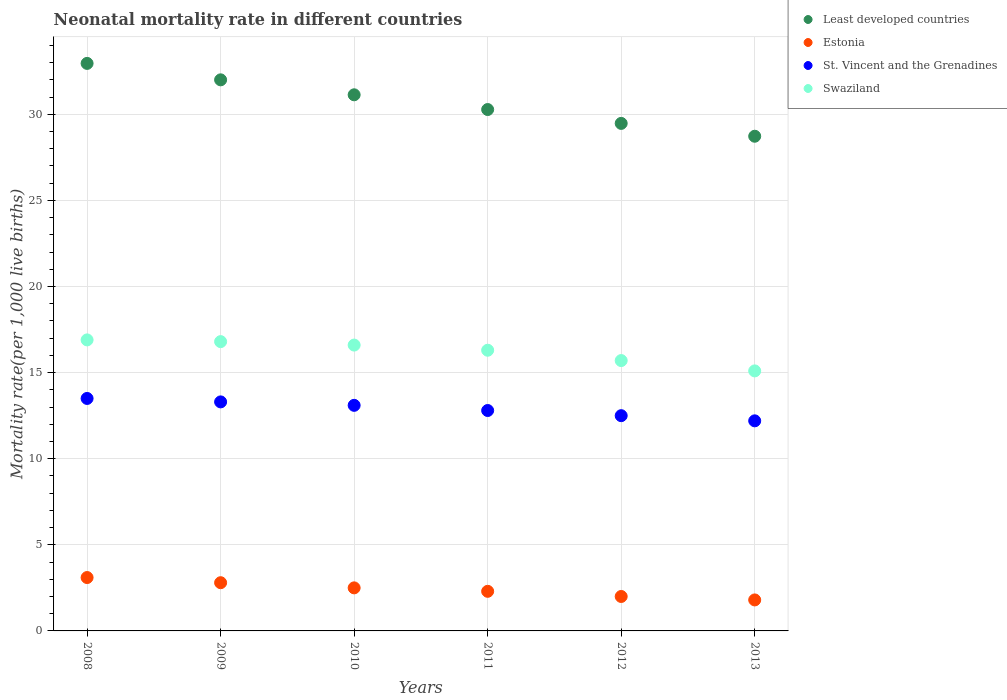How many different coloured dotlines are there?
Ensure brevity in your answer.  4. What is the neonatal mortality rate in Estonia in 2011?
Your response must be concise. 2.3. Across all years, what is the minimum neonatal mortality rate in Least developed countries?
Make the answer very short. 28.73. In which year was the neonatal mortality rate in Swaziland maximum?
Offer a very short reply. 2008. What is the total neonatal mortality rate in Estonia in the graph?
Your response must be concise. 14.5. What is the difference between the neonatal mortality rate in Least developed countries in 2009 and that in 2010?
Keep it short and to the point. 0.87. What is the difference between the neonatal mortality rate in St. Vincent and the Grenadines in 2008 and the neonatal mortality rate in Least developed countries in 2009?
Offer a very short reply. -18.5. What is the average neonatal mortality rate in Estonia per year?
Your response must be concise. 2.42. In the year 2013, what is the difference between the neonatal mortality rate in Swaziland and neonatal mortality rate in St. Vincent and the Grenadines?
Give a very brief answer. 2.9. In how many years, is the neonatal mortality rate in Swaziland greater than 6?
Your answer should be compact. 6. What is the ratio of the neonatal mortality rate in Least developed countries in 2011 to that in 2012?
Your answer should be compact. 1.03. Is the difference between the neonatal mortality rate in Swaziland in 2011 and 2012 greater than the difference between the neonatal mortality rate in St. Vincent and the Grenadines in 2011 and 2012?
Offer a terse response. Yes. What is the difference between the highest and the second highest neonatal mortality rate in Least developed countries?
Offer a very short reply. 0.95. What is the difference between the highest and the lowest neonatal mortality rate in Swaziland?
Provide a short and direct response. 1.8. Is it the case that in every year, the sum of the neonatal mortality rate in St. Vincent and the Grenadines and neonatal mortality rate in Least developed countries  is greater than the sum of neonatal mortality rate in Swaziland and neonatal mortality rate in Estonia?
Offer a very short reply. Yes. Is the neonatal mortality rate in Least developed countries strictly greater than the neonatal mortality rate in Estonia over the years?
Offer a very short reply. Yes. Is the neonatal mortality rate in Swaziland strictly less than the neonatal mortality rate in St. Vincent and the Grenadines over the years?
Provide a succinct answer. No. How many years are there in the graph?
Your response must be concise. 6. What is the difference between two consecutive major ticks on the Y-axis?
Give a very brief answer. 5. Does the graph contain any zero values?
Offer a very short reply. No. Does the graph contain grids?
Your response must be concise. Yes. Where does the legend appear in the graph?
Your response must be concise. Top right. What is the title of the graph?
Your answer should be compact. Neonatal mortality rate in different countries. What is the label or title of the Y-axis?
Provide a succinct answer. Mortality rate(per 1,0 live births). What is the Mortality rate(per 1,000 live births) of Least developed countries in 2008?
Make the answer very short. 32.96. What is the Mortality rate(per 1,000 live births) in St. Vincent and the Grenadines in 2008?
Your answer should be compact. 13.5. What is the Mortality rate(per 1,000 live births) in Least developed countries in 2009?
Offer a terse response. 32. What is the Mortality rate(per 1,000 live births) in St. Vincent and the Grenadines in 2009?
Your answer should be compact. 13.3. What is the Mortality rate(per 1,000 live births) in Least developed countries in 2010?
Provide a succinct answer. 31.13. What is the Mortality rate(per 1,000 live births) in Estonia in 2010?
Keep it short and to the point. 2.5. What is the Mortality rate(per 1,000 live births) of St. Vincent and the Grenadines in 2010?
Your answer should be compact. 13.1. What is the Mortality rate(per 1,000 live births) in Least developed countries in 2011?
Your response must be concise. 30.28. What is the Mortality rate(per 1,000 live births) in Estonia in 2011?
Offer a terse response. 2.3. What is the Mortality rate(per 1,000 live births) of St. Vincent and the Grenadines in 2011?
Provide a short and direct response. 12.8. What is the Mortality rate(per 1,000 live births) in Least developed countries in 2012?
Provide a short and direct response. 29.47. What is the Mortality rate(per 1,000 live births) of Estonia in 2012?
Give a very brief answer. 2. What is the Mortality rate(per 1,000 live births) in Least developed countries in 2013?
Provide a succinct answer. 28.73. What is the Mortality rate(per 1,000 live births) in St. Vincent and the Grenadines in 2013?
Offer a terse response. 12.2. Across all years, what is the maximum Mortality rate(per 1,000 live births) of Least developed countries?
Make the answer very short. 32.96. Across all years, what is the maximum Mortality rate(per 1,000 live births) in Swaziland?
Offer a terse response. 16.9. Across all years, what is the minimum Mortality rate(per 1,000 live births) of Least developed countries?
Provide a short and direct response. 28.73. Across all years, what is the minimum Mortality rate(per 1,000 live births) of Estonia?
Your answer should be very brief. 1.8. Across all years, what is the minimum Mortality rate(per 1,000 live births) in Swaziland?
Offer a terse response. 15.1. What is the total Mortality rate(per 1,000 live births) in Least developed countries in the graph?
Make the answer very short. 184.57. What is the total Mortality rate(per 1,000 live births) in Estonia in the graph?
Your answer should be very brief. 14.5. What is the total Mortality rate(per 1,000 live births) of St. Vincent and the Grenadines in the graph?
Your response must be concise. 77.4. What is the total Mortality rate(per 1,000 live births) of Swaziland in the graph?
Provide a succinct answer. 97.4. What is the difference between the Mortality rate(per 1,000 live births) of Least developed countries in 2008 and that in 2009?
Your response must be concise. 0.95. What is the difference between the Mortality rate(per 1,000 live births) in Estonia in 2008 and that in 2009?
Your answer should be compact. 0.3. What is the difference between the Mortality rate(per 1,000 live births) in Least developed countries in 2008 and that in 2010?
Make the answer very short. 1.82. What is the difference between the Mortality rate(per 1,000 live births) of Estonia in 2008 and that in 2010?
Your response must be concise. 0.6. What is the difference between the Mortality rate(per 1,000 live births) of Swaziland in 2008 and that in 2010?
Give a very brief answer. 0.3. What is the difference between the Mortality rate(per 1,000 live births) of Least developed countries in 2008 and that in 2011?
Ensure brevity in your answer.  2.68. What is the difference between the Mortality rate(per 1,000 live births) in St. Vincent and the Grenadines in 2008 and that in 2011?
Provide a short and direct response. 0.7. What is the difference between the Mortality rate(per 1,000 live births) in Swaziland in 2008 and that in 2011?
Provide a succinct answer. 0.6. What is the difference between the Mortality rate(per 1,000 live births) of Least developed countries in 2008 and that in 2012?
Offer a very short reply. 3.48. What is the difference between the Mortality rate(per 1,000 live births) in St. Vincent and the Grenadines in 2008 and that in 2012?
Make the answer very short. 1. What is the difference between the Mortality rate(per 1,000 live births) of Swaziland in 2008 and that in 2012?
Offer a very short reply. 1.2. What is the difference between the Mortality rate(per 1,000 live births) in Least developed countries in 2008 and that in 2013?
Provide a succinct answer. 4.23. What is the difference between the Mortality rate(per 1,000 live births) of St. Vincent and the Grenadines in 2008 and that in 2013?
Your answer should be very brief. 1.3. What is the difference between the Mortality rate(per 1,000 live births) of Least developed countries in 2009 and that in 2010?
Your answer should be very brief. 0.87. What is the difference between the Mortality rate(per 1,000 live births) of Estonia in 2009 and that in 2010?
Make the answer very short. 0.3. What is the difference between the Mortality rate(per 1,000 live births) of Least developed countries in 2009 and that in 2011?
Your answer should be compact. 1.72. What is the difference between the Mortality rate(per 1,000 live births) in Least developed countries in 2009 and that in 2012?
Your answer should be very brief. 2.53. What is the difference between the Mortality rate(per 1,000 live births) of Swaziland in 2009 and that in 2012?
Give a very brief answer. 1.1. What is the difference between the Mortality rate(per 1,000 live births) of Least developed countries in 2009 and that in 2013?
Give a very brief answer. 3.28. What is the difference between the Mortality rate(per 1,000 live births) of St. Vincent and the Grenadines in 2009 and that in 2013?
Your answer should be compact. 1.1. What is the difference between the Mortality rate(per 1,000 live births) of Least developed countries in 2010 and that in 2011?
Provide a succinct answer. 0.86. What is the difference between the Mortality rate(per 1,000 live births) of Swaziland in 2010 and that in 2011?
Offer a very short reply. 0.3. What is the difference between the Mortality rate(per 1,000 live births) in Least developed countries in 2010 and that in 2012?
Make the answer very short. 1.66. What is the difference between the Mortality rate(per 1,000 live births) in Swaziland in 2010 and that in 2012?
Your response must be concise. 0.9. What is the difference between the Mortality rate(per 1,000 live births) of Least developed countries in 2010 and that in 2013?
Keep it short and to the point. 2.41. What is the difference between the Mortality rate(per 1,000 live births) of Estonia in 2010 and that in 2013?
Offer a terse response. 0.7. What is the difference between the Mortality rate(per 1,000 live births) in Swaziland in 2010 and that in 2013?
Offer a terse response. 1.5. What is the difference between the Mortality rate(per 1,000 live births) of Least developed countries in 2011 and that in 2012?
Your answer should be compact. 0.81. What is the difference between the Mortality rate(per 1,000 live births) in Estonia in 2011 and that in 2012?
Keep it short and to the point. 0.3. What is the difference between the Mortality rate(per 1,000 live births) in St. Vincent and the Grenadines in 2011 and that in 2012?
Keep it short and to the point. 0.3. What is the difference between the Mortality rate(per 1,000 live births) of Least developed countries in 2011 and that in 2013?
Give a very brief answer. 1.55. What is the difference between the Mortality rate(per 1,000 live births) of Estonia in 2011 and that in 2013?
Keep it short and to the point. 0.5. What is the difference between the Mortality rate(per 1,000 live births) of Swaziland in 2011 and that in 2013?
Make the answer very short. 1.2. What is the difference between the Mortality rate(per 1,000 live births) in Least developed countries in 2012 and that in 2013?
Give a very brief answer. 0.75. What is the difference between the Mortality rate(per 1,000 live births) of St. Vincent and the Grenadines in 2012 and that in 2013?
Provide a succinct answer. 0.3. What is the difference between the Mortality rate(per 1,000 live births) of Swaziland in 2012 and that in 2013?
Provide a short and direct response. 0.6. What is the difference between the Mortality rate(per 1,000 live births) in Least developed countries in 2008 and the Mortality rate(per 1,000 live births) in Estonia in 2009?
Your answer should be very brief. 30.16. What is the difference between the Mortality rate(per 1,000 live births) in Least developed countries in 2008 and the Mortality rate(per 1,000 live births) in St. Vincent and the Grenadines in 2009?
Your response must be concise. 19.66. What is the difference between the Mortality rate(per 1,000 live births) in Least developed countries in 2008 and the Mortality rate(per 1,000 live births) in Swaziland in 2009?
Keep it short and to the point. 16.16. What is the difference between the Mortality rate(per 1,000 live births) in Estonia in 2008 and the Mortality rate(per 1,000 live births) in St. Vincent and the Grenadines in 2009?
Your response must be concise. -10.2. What is the difference between the Mortality rate(per 1,000 live births) of Estonia in 2008 and the Mortality rate(per 1,000 live births) of Swaziland in 2009?
Provide a succinct answer. -13.7. What is the difference between the Mortality rate(per 1,000 live births) in St. Vincent and the Grenadines in 2008 and the Mortality rate(per 1,000 live births) in Swaziland in 2009?
Ensure brevity in your answer.  -3.3. What is the difference between the Mortality rate(per 1,000 live births) in Least developed countries in 2008 and the Mortality rate(per 1,000 live births) in Estonia in 2010?
Give a very brief answer. 30.46. What is the difference between the Mortality rate(per 1,000 live births) in Least developed countries in 2008 and the Mortality rate(per 1,000 live births) in St. Vincent and the Grenadines in 2010?
Offer a very short reply. 19.86. What is the difference between the Mortality rate(per 1,000 live births) in Least developed countries in 2008 and the Mortality rate(per 1,000 live births) in Swaziland in 2010?
Give a very brief answer. 16.36. What is the difference between the Mortality rate(per 1,000 live births) in Estonia in 2008 and the Mortality rate(per 1,000 live births) in Swaziland in 2010?
Your response must be concise. -13.5. What is the difference between the Mortality rate(per 1,000 live births) in Least developed countries in 2008 and the Mortality rate(per 1,000 live births) in Estonia in 2011?
Make the answer very short. 30.66. What is the difference between the Mortality rate(per 1,000 live births) of Least developed countries in 2008 and the Mortality rate(per 1,000 live births) of St. Vincent and the Grenadines in 2011?
Your response must be concise. 20.16. What is the difference between the Mortality rate(per 1,000 live births) of Least developed countries in 2008 and the Mortality rate(per 1,000 live births) of Swaziland in 2011?
Your response must be concise. 16.66. What is the difference between the Mortality rate(per 1,000 live births) of Estonia in 2008 and the Mortality rate(per 1,000 live births) of St. Vincent and the Grenadines in 2011?
Make the answer very short. -9.7. What is the difference between the Mortality rate(per 1,000 live births) of Estonia in 2008 and the Mortality rate(per 1,000 live births) of Swaziland in 2011?
Your answer should be very brief. -13.2. What is the difference between the Mortality rate(per 1,000 live births) in St. Vincent and the Grenadines in 2008 and the Mortality rate(per 1,000 live births) in Swaziland in 2011?
Your response must be concise. -2.8. What is the difference between the Mortality rate(per 1,000 live births) of Least developed countries in 2008 and the Mortality rate(per 1,000 live births) of Estonia in 2012?
Give a very brief answer. 30.96. What is the difference between the Mortality rate(per 1,000 live births) of Least developed countries in 2008 and the Mortality rate(per 1,000 live births) of St. Vincent and the Grenadines in 2012?
Your answer should be very brief. 20.46. What is the difference between the Mortality rate(per 1,000 live births) of Least developed countries in 2008 and the Mortality rate(per 1,000 live births) of Swaziland in 2012?
Make the answer very short. 17.26. What is the difference between the Mortality rate(per 1,000 live births) of Estonia in 2008 and the Mortality rate(per 1,000 live births) of St. Vincent and the Grenadines in 2012?
Provide a succinct answer. -9.4. What is the difference between the Mortality rate(per 1,000 live births) in Least developed countries in 2008 and the Mortality rate(per 1,000 live births) in Estonia in 2013?
Your answer should be compact. 31.16. What is the difference between the Mortality rate(per 1,000 live births) of Least developed countries in 2008 and the Mortality rate(per 1,000 live births) of St. Vincent and the Grenadines in 2013?
Your answer should be compact. 20.76. What is the difference between the Mortality rate(per 1,000 live births) in Least developed countries in 2008 and the Mortality rate(per 1,000 live births) in Swaziland in 2013?
Your answer should be very brief. 17.86. What is the difference between the Mortality rate(per 1,000 live births) of Least developed countries in 2009 and the Mortality rate(per 1,000 live births) of Estonia in 2010?
Your answer should be very brief. 29.5. What is the difference between the Mortality rate(per 1,000 live births) in Least developed countries in 2009 and the Mortality rate(per 1,000 live births) in St. Vincent and the Grenadines in 2010?
Keep it short and to the point. 18.9. What is the difference between the Mortality rate(per 1,000 live births) of Least developed countries in 2009 and the Mortality rate(per 1,000 live births) of Swaziland in 2010?
Offer a terse response. 15.4. What is the difference between the Mortality rate(per 1,000 live births) in Estonia in 2009 and the Mortality rate(per 1,000 live births) in Swaziland in 2010?
Provide a short and direct response. -13.8. What is the difference between the Mortality rate(per 1,000 live births) in St. Vincent and the Grenadines in 2009 and the Mortality rate(per 1,000 live births) in Swaziland in 2010?
Your answer should be very brief. -3.3. What is the difference between the Mortality rate(per 1,000 live births) of Least developed countries in 2009 and the Mortality rate(per 1,000 live births) of Estonia in 2011?
Provide a short and direct response. 29.7. What is the difference between the Mortality rate(per 1,000 live births) of Least developed countries in 2009 and the Mortality rate(per 1,000 live births) of St. Vincent and the Grenadines in 2011?
Ensure brevity in your answer.  19.2. What is the difference between the Mortality rate(per 1,000 live births) of Least developed countries in 2009 and the Mortality rate(per 1,000 live births) of Swaziland in 2011?
Provide a short and direct response. 15.7. What is the difference between the Mortality rate(per 1,000 live births) in Estonia in 2009 and the Mortality rate(per 1,000 live births) in Swaziland in 2011?
Ensure brevity in your answer.  -13.5. What is the difference between the Mortality rate(per 1,000 live births) in Least developed countries in 2009 and the Mortality rate(per 1,000 live births) in Estonia in 2012?
Your response must be concise. 30. What is the difference between the Mortality rate(per 1,000 live births) in Least developed countries in 2009 and the Mortality rate(per 1,000 live births) in St. Vincent and the Grenadines in 2012?
Ensure brevity in your answer.  19.5. What is the difference between the Mortality rate(per 1,000 live births) of Least developed countries in 2009 and the Mortality rate(per 1,000 live births) of Swaziland in 2012?
Provide a succinct answer. 16.3. What is the difference between the Mortality rate(per 1,000 live births) of Estonia in 2009 and the Mortality rate(per 1,000 live births) of St. Vincent and the Grenadines in 2012?
Make the answer very short. -9.7. What is the difference between the Mortality rate(per 1,000 live births) in St. Vincent and the Grenadines in 2009 and the Mortality rate(per 1,000 live births) in Swaziland in 2012?
Your answer should be very brief. -2.4. What is the difference between the Mortality rate(per 1,000 live births) of Least developed countries in 2009 and the Mortality rate(per 1,000 live births) of Estonia in 2013?
Ensure brevity in your answer.  30.2. What is the difference between the Mortality rate(per 1,000 live births) of Least developed countries in 2009 and the Mortality rate(per 1,000 live births) of St. Vincent and the Grenadines in 2013?
Make the answer very short. 19.8. What is the difference between the Mortality rate(per 1,000 live births) of Least developed countries in 2009 and the Mortality rate(per 1,000 live births) of Swaziland in 2013?
Your answer should be very brief. 16.9. What is the difference between the Mortality rate(per 1,000 live births) of Estonia in 2009 and the Mortality rate(per 1,000 live births) of Swaziland in 2013?
Offer a terse response. -12.3. What is the difference between the Mortality rate(per 1,000 live births) in Least developed countries in 2010 and the Mortality rate(per 1,000 live births) in Estonia in 2011?
Make the answer very short. 28.83. What is the difference between the Mortality rate(per 1,000 live births) of Least developed countries in 2010 and the Mortality rate(per 1,000 live births) of St. Vincent and the Grenadines in 2011?
Provide a short and direct response. 18.33. What is the difference between the Mortality rate(per 1,000 live births) in Least developed countries in 2010 and the Mortality rate(per 1,000 live births) in Swaziland in 2011?
Your response must be concise. 14.83. What is the difference between the Mortality rate(per 1,000 live births) of Estonia in 2010 and the Mortality rate(per 1,000 live births) of St. Vincent and the Grenadines in 2011?
Provide a succinct answer. -10.3. What is the difference between the Mortality rate(per 1,000 live births) in St. Vincent and the Grenadines in 2010 and the Mortality rate(per 1,000 live births) in Swaziland in 2011?
Ensure brevity in your answer.  -3.2. What is the difference between the Mortality rate(per 1,000 live births) of Least developed countries in 2010 and the Mortality rate(per 1,000 live births) of Estonia in 2012?
Give a very brief answer. 29.13. What is the difference between the Mortality rate(per 1,000 live births) in Least developed countries in 2010 and the Mortality rate(per 1,000 live births) in St. Vincent and the Grenadines in 2012?
Give a very brief answer. 18.63. What is the difference between the Mortality rate(per 1,000 live births) of Least developed countries in 2010 and the Mortality rate(per 1,000 live births) of Swaziland in 2012?
Keep it short and to the point. 15.43. What is the difference between the Mortality rate(per 1,000 live births) in Estonia in 2010 and the Mortality rate(per 1,000 live births) in Swaziland in 2012?
Provide a short and direct response. -13.2. What is the difference between the Mortality rate(per 1,000 live births) in Least developed countries in 2010 and the Mortality rate(per 1,000 live births) in Estonia in 2013?
Your answer should be compact. 29.33. What is the difference between the Mortality rate(per 1,000 live births) in Least developed countries in 2010 and the Mortality rate(per 1,000 live births) in St. Vincent and the Grenadines in 2013?
Your answer should be compact. 18.93. What is the difference between the Mortality rate(per 1,000 live births) in Least developed countries in 2010 and the Mortality rate(per 1,000 live births) in Swaziland in 2013?
Your response must be concise. 16.03. What is the difference between the Mortality rate(per 1,000 live births) in Estonia in 2010 and the Mortality rate(per 1,000 live births) in Swaziland in 2013?
Your response must be concise. -12.6. What is the difference between the Mortality rate(per 1,000 live births) of Least developed countries in 2011 and the Mortality rate(per 1,000 live births) of Estonia in 2012?
Give a very brief answer. 28.28. What is the difference between the Mortality rate(per 1,000 live births) of Least developed countries in 2011 and the Mortality rate(per 1,000 live births) of St. Vincent and the Grenadines in 2012?
Ensure brevity in your answer.  17.78. What is the difference between the Mortality rate(per 1,000 live births) of Least developed countries in 2011 and the Mortality rate(per 1,000 live births) of Swaziland in 2012?
Provide a succinct answer. 14.58. What is the difference between the Mortality rate(per 1,000 live births) of Estonia in 2011 and the Mortality rate(per 1,000 live births) of St. Vincent and the Grenadines in 2012?
Offer a terse response. -10.2. What is the difference between the Mortality rate(per 1,000 live births) of Least developed countries in 2011 and the Mortality rate(per 1,000 live births) of Estonia in 2013?
Your answer should be compact. 28.48. What is the difference between the Mortality rate(per 1,000 live births) of Least developed countries in 2011 and the Mortality rate(per 1,000 live births) of St. Vincent and the Grenadines in 2013?
Give a very brief answer. 18.08. What is the difference between the Mortality rate(per 1,000 live births) of Least developed countries in 2011 and the Mortality rate(per 1,000 live births) of Swaziland in 2013?
Provide a succinct answer. 15.18. What is the difference between the Mortality rate(per 1,000 live births) in Estonia in 2011 and the Mortality rate(per 1,000 live births) in St. Vincent and the Grenadines in 2013?
Keep it short and to the point. -9.9. What is the difference between the Mortality rate(per 1,000 live births) in Estonia in 2011 and the Mortality rate(per 1,000 live births) in Swaziland in 2013?
Provide a succinct answer. -12.8. What is the difference between the Mortality rate(per 1,000 live births) of St. Vincent and the Grenadines in 2011 and the Mortality rate(per 1,000 live births) of Swaziland in 2013?
Give a very brief answer. -2.3. What is the difference between the Mortality rate(per 1,000 live births) of Least developed countries in 2012 and the Mortality rate(per 1,000 live births) of Estonia in 2013?
Offer a very short reply. 27.67. What is the difference between the Mortality rate(per 1,000 live births) of Least developed countries in 2012 and the Mortality rate(per 1,000 live births) of St. Vincent and the Grenadines in 2013?
Your answer should be very brief. 17.27. What is the difference between the Mortality rate(per 1,000 live births) in Least developed countries in 2012 and the Mortality rate(per 1,000 live births) in Swaziland in 2013?
Give a very brief answer. 14.37. What is the difference between the Mortality rate(per 1,000 live births) in Estonia in 2012 and the Mortality rate(per 1,000 live births) in Swaziland in 2013?
Provide a short and direct response. -13.1. What is the difference between the Mortality rate(per 1,000 live births) of St. Vincent and the Grenadines in 2012 and the Mortality rate(per 1,000 live births) of Swaziland in 2013?
Offer a very short reply. -2.6. What is the average Mortality rate(per 1,000 live births) of Least developed countries per year?
Ensure brevity in your answer.  30.76. What is the average Mortality rate(per 1,000 live births) of Estonia per year?
Your answer should be compact. 2.42. What is the average Mortality rate(per 1,000 live births) in Swaziland per year?
Offer a terse response. 16.23. In the year 2008, what is the difference between the Mortality rate(per 1,000 live births) in Least developed countries and Mortality rate(per 1,000 live births) in Estonia?
Offer a very short reply. 29.86. In the year 2008, what is the difference between the Mortality rate(per 1,000 live births) of Least developed countries and Mortality rate(per 1,000 live births) of St. Vincent and the Grenadines?
Provide a succinct answer. 19.46. In the year 2008, what is the difference between the Mortality rate(per 1,000 live births) of Least developed countries and Mortality rate(per 1,000 live births) of Swaziland?
Provide a succinct answer. 16.06. In the year 2008, what is the difference between the Mortality rate(per 1,000 live births) of Estonia and Mortality rate(per 1,000 live births) of St. Vincent and the Grenadines?
Give a very brief answer. -10.4. In the year 2009, what is the difference between the Mortality rate(per 1,000 live births) of Least developed countries and Mortality rate(per 1,000 live births) of Estonia?
Offer a very short reply. 29.2. In the year 2009, what is the difference between the Mortality rate(per 1,000 live births) in Least developed countries and Mortality rate(per 1,000 live births) in St. Vincent and the Grenadines?
Ensure brevity in your answer.  18.7. In the year 2009, what is the difference between the Mortality rate(per 1,000 live births) of Least developed countries and Mortality rate(per 1,000 live births) of Swaziland?
Your answer should be very brief. 15.2. In the year 2009, what is the difference between the Mortality rate(per 1,000 live births) of Estonia and Mortality rate(per 1,000 live births) of St. Vincent and the Grenadines?
Your answer should be very brief. -10.5. In the year 2009, what is the difference between the Mortality rate(per 1,000 live births) of Estonia and Mortality rate(per 1,000 live births) of Swaziland?
Keep it short and to the point. -14. In the year 2010, what is the difference between the Mortality rate(per 1,000 live births) of Least developed countries and Mortality rate(per 1,000 live births) of Estonia?
Ensure brevity in your answer.  28.63. In the year 2010, what is the difference between the Mortality rate(per 1,000 live births) of Least developed countries and Mortality rate(per 1,000 live births) of St. Vincent and the Grenadines?
Offer a terse response. 18.03. In the year 2010, what is the difference between the Mortality rate(per 1,000 live births) in Least developed countries and Mortality rate(per 1,000 live births) in Swaziland?
Provide a short and direct response. 14.53. In the year 2010, what is the difference between the Mortality rate(per 1,000 live births) of Estonia and Mortality rate(per 1,000 live births) of St. Vincent and the Grenadines?
Keep it short and to the point. -10.6. In the year 2010, what is the difference between the Mortality rate(per 1,000 live births) of Estonia and Mortality rate(per 1,000 live births) of Swaziland?
Keep it short and to the point. -14.1. In the year 2010, what is the difference between the Mortality rate(per 1,000 live births) of St. Vincent and the Grenadines and Mortality rate(per 1,000 live births) of Swaziland?
Offer a terse response. -3.5. In the year 2011, what is the difference between the Mortality rate(per 1,000 live births) in Least developed countries and Mortality rate(per 1,000 live births) in Estonia?
Offer a terse response. 27.98. In the year 2011, what is the difference between the Mortality rate(per 1,000 live births) in Least developed countries and Mortality rate(per 1,000 live births) in St. Vincent and the Grenadines?
Keep it short and to the point. 17.48. In the year 2011, what is the difference between the Mortality rate(per 1,000 live births) in Least developed countries and Mortality rate(per 1,000 live births) in Swaziland?
Keep it short and to the point. 13.98. In the year 2011, what is the difference between the Mortality rate(per 1,000 live births) of Estonia and Mortality rate(per 1,000 live births) of St. Vincent and the Grenadines?
Your response must be concise. -10.5. In the year 2011, what is the difference between the Mortality rate(per 1,000 live births) in Estonia and Mortality rate(per 1,000 live births) in Swaziland?
Offer a terse response. -14. In the year 2011, what is the difference between the Mortality rate(per 1,000 live births) of St. Vincent and the Grenadines and Mortality rate(per 1,000 live births) of Swaziland?
Offer a very short reply. -3.5. In the year 2012, what is the difference between the Mortality rate(per 1,000 live births) of Least developed countries and Mortality rate(per 1,000 live births) of Estonia?
Give a very brief answer. 27.47. In the year 2012, what is the difference between the Mortality rate(per 1,000 live births) of Least developed countries and Mortality rate(per 1,000 live births) of St. Vincent and the Grenadines?
Your answer should be compact. 16.97. In the year 2012, what is the difference between the Mortality rate(per 1,000 live births) of Least developed countries and Mortality rate(per 1,000 live births) of Swaziland?
Your response must be concise. 13.77. In the year 2012, what is the difference between the Mortality rate(per 1,000 live births) in Estonia and Mortality rate(per 1,000 live births) in Swaziland?
Ensure brevity in your answer.  -13.7. In the year 2012, what is the difference between the Mortality rate(per 1,000 live births) of St. Vincent and the Grenadines and Mortality rate(per 1,000 live births) of Swaziland?
Your answer should be compact. -3.2. In the year 2013, what is the difference between the Mortality rate(per 1,000 live births) of Least developed countries and Mortality rate(per 1,000 live births) of Estonia?
Offer a very short reply. 26.93. In the year 2013, what is the difference between the Mortality rate(per 1,000 live births) of Least developed countries and Mortality rate(per 1,000 live births) of St. Vincent and the Grenadines?
Keep it short and to the point. 16.53. In the year 2013, what is the difference between the Mortality rate(per 1,000 live births) in Least developed countries and Mortality rate(per 1,000 live births) in Swaziland?
Offer a very short reply. 13.63. In the year 2013, what is the difference between the Mortality rate(per 1,000 live births) of Estonia and Mortality rate(per 1,000 live births) of Swaziland?
Provide a short and direct response. -13.3. In the year 2013, what is the difference between the Mortality rate(per 1,000 live births) in St. Vincent and the Grenadines and Mortality rate(per 1,000 live births) in Swaziland?
Provide a short and direct response. -2.9. What is the ratio of the Mortality rate(per 1,000 live births) of Least developed countries in 2008 to that in 2009?
Provide a short and direct response. 1.03. What is the ratio of the Mortality rate(per 1,000 live births) in Estonia in 2008 to that in 2009?
Your response must be concise. 1.11. What is the ratio of the Mortality rate(per 1,000 live births) of Least developed countries in 2008 to that in 2010?
Offer a very short reply. 1.06. What is the ratio of the Mortality rate(per 1,000 live births) in Estonia in 2008 to that in 2010?
Provide a succinct answer. 1.24. What is the ratio of the Mortality rate(per 1,000 live births) of St. Vincent and the Grenadines in 2008 to that in 2010?
Your response must be concise. 1.03. What is the ratio of the Mortality rate(per 1,000 live births) of Swaziland in 2008 to that in 2010?
Make the answer very short. 1.02. What is the ratio of the Mortality rate(per 1,000 live births) of Least developed countries in 2008 to that in 2011?
Your answer should be compact. 1.09. What is the ratio of the Mortality rate(per 1,000 live births) of Estonia in 2008 to that in 2011?
Your response must be concise. 1.35. What is the ratio of the Mortality rate(per 1,000 live births) in St. Vincent and the Grenadines in 2008 to that in 2011?
Provide a succinct answer. 1.05. What is the ratio of the Mortality rate(per 1,000 live births) of Swaziland in 2008 to that in 2011?
Make the answer very short. 1.04. What is the ratio of the Mortality rate(per 1,000 live births) in Least developed countries in 2008 to that in 2012?
Keep it short and to the point. 1.12. What is the ratio of the Mortality rate(per 1,000 live births) in Estonia in 2008 to that in 2012?
Provide a short and direct response. 1.55. What is the ratio of the Mortality rate(per 1,000 live births) in St. Vincent and the Grenadines in 2008 to that in 2012?
Provide a succinct answer. 1.08. What is the ratio of the Mortality rate(per 1,000 live births) in Swaziland in 2008 to that in 2012?
Offer a very short reply. 1.08. What is the ratio of the Mortality rate(per 1,000 live births) in Least developed countries in 2008 to that in 2013?
Your answer should be compact. 1.15. What is the ratio of the Mortality rate(per 1,000 live births) in Estonia in 2008 to that in 2013?
Provide a succinct answer. 1.72. What is the ratio of the Mortality rate(per 1,000 live births) of St. Vincent and the Grenadines in 2008 to that in 2013?
Give a very brief answer. 1.11. What is the ratio of the Mortality rate(per 1,000 live births) of Swaziland in 2008 to that in 2013?
Your answer should be compact. 1.12. What is the ratio of the Mortality rate(per 1,000 live births) of Least developed countries in 2009 to that in 2010?
Your answer should be compact. 1.03. What is the ratio of the Mortality rate(per 1,000 live births) of Estonia in 2009 to that in 2010?
Offer a very short reply. 1.12. What is the ratio of the Mortality rate(per 1,000 live births) of St. Vincent and the Grenadines in 2009 to that in 2010?
Your response must be concise. 1.02. What is the ratio of the Mortality rate(per 1,000 live births) of Swaziland in 2009 to that in 2010?
Offer a terse response. 1.01. What is the ratio of the Mortality rate(per 1,000 live births) of Least developed countries in 2009 to that in 2011?
Offer a terse response. 1.06. What is the ratio of the Mortality rate(per 1,000 live births) of Estonia in 2009 to that in 2011?
Your response must be concise. 1.22. What is the ratio of the Mortality rate(per 1,000 live births) of St. Vincent and the Grenadines in 2009 to that in 2011?
Offer a very short reply. 1.04. What is the ratio of the Mortality rate(per 1,000 live births) of Swaziland in 2009 to that in 2011?
Your answer should be compact. 1.03. What is the ratio of the Mortality rate(per 1,000 live births) of Least developed countries in 2009 to that in 2012?
Your answer should be very brief. 1.09. What is the ratio of the Mortality rate(per 1,000 live births) in St. Vincent and the Grenadines in 2009 to that in 2012?
Ensure brevity in your answer.  1.06. What is the ratio of the Mortality rate(per 1,000 live births) of Swaziland in 2009 to that in 2012?
Offer a terse response. 1.07. What is the ratio of the Mortality rate(per 1,000 live births) in Least developed countries in 2009 to that in 2013?
Keep it short and to the point. 1.11. What is the ratio of the Mortality rate(per 1,000 live births) of Estonia in 2009 to that in 2013?
Offer a terse response. 1.56. What is the ratio of the Mortality rate(per 1,000 live births) of St. Vincent and the Grenadines in 2009 to that in 2013?
Offer a terse response. 1.09. What is the ratio of the Mortality rate(per 1,000 live births) of Swaziland in 2009 to that in 2013?
Your answer should be very brief. 1.11. What is the ratio of the Mortality rate(per 1,000 live births) in Least developed countries in 2010 to that in 2011?
Ensure brevity in your answer.  1.03. What is the ratio of the Mortality rate(per 1,000 live births) in Estonia in 2010 to that in 2011?
Make the answer very short. 1.09. What is the ratio of the Mortality rate(per 1,000 live births) of St. Vincent and the Grenadines in 2010 to that in 2011?
Keep it short and to the point. 1.02. What is the ratio of the Mortality rate(per 1,000 live births) of Swaziland in 2010 to that in 2011?
Offer a very short reply. 1.02. What is the ratio of the Mortality rate(per 1,000 live births) of Least developed countries in 2010 to that in 2012?
Offer a very short reply. 1.06. What is the ratio of the Mortality rate(per 1,000 live births) in Estonia in 2010 to that in 2012?
Your response must be concise. 1.25. What is the ratio of the Mortality rate(per 1,000 live births) in St. Vincent and the Grenadines in 2010 to that in 2012?
Offer a very short reply. 1.05. What is the ratio of the Mortality rate(per 1,000 live births) of Swaziland in 2010 to that in 2012?
Your answer should be compact. 1.06. What is the ratio of the Mortality rate(per 1,000 live births) of Least developed countries in 2010 to that in 2013?
Provide a short and direct response. 1.08. What is the ratio of the Mortality rate(per 1,000 live births) of Estonia in 2010 to that in 2013?
Ensure brevity in your answer.  1.39. What is the ratio of the Mortality rate(per 1,000 live births) of St. Vincent and the Grenadines in 2010 to that in 2013?
Your response must be concise. 1.07. What is the ratio of the Mortality rate(per 1,000 live births) of Swaziland in 2010 to that in 2013?
Make the answer very short. 1.1. What is the ratio of the Mortality rate(per 1,000 live births) in Least developed countries in 2011 to that in 2012?
Provide a succinct answer. 1.03. What is the ratio of the Mortality rate(per 1,000 live births) in Estonia in 2011 to that in 2012?
Provide a succinct answer. 1.15. What is the ratio of the Mortality rate(per 1,000 live births) of Swaziland in 2011 to that in 2012?
Make the answer very short. 1.04. What is the ratio of the Mortality rate(per 1,000 live births) in Least developed countries in 2011 to that in 2013?
Make the answer very short. 1.05. What is the ratio of the Mortality rate(per 1,000 live births) of Estonia in 2011 to that in 2013?
Your answer should be very brief. 1.28. What is the ratio of the Mortality rate(per 1,000 live births) of St. Vincent and the Grenadines in 2011 to that in 2013?
Offer a terse response. 1.05. What is the ratio of the Mortality rate(per 1,000 live births) of Swaziland in 2011 to that in 2013?
Offer a terse response. 1.08. What is the ratio of the Mortality rate(per 1,000 live births) of Least developed countries in 2012 to that in 2013?
Provide a short and direct response. 1.03. What is the ratio of the Mortality rate(per 1,000 live births) of St. Vincent and the Grenadines in 2012 to that in 2013?
Offer a terse response. 1.02. What is the ratio of the Mortality rate(per 1,000 live births) of Swaziland in 2012 to that in 2013?
Your answer should be compact. 1.04. What is the difference between the highest and the second highest Mortality rate(per 1,000 live births) in Least developed countries?
Give a very brief answer. 0.95. What is the difference between the highest and the second highest Mortality rate(per 1,000 live births) in St. Vincent and the Grenadines?
Your response must be concise. 0.2. What is the difference between the highest and the lowest Mortality rate(per 1,000 live births) of Least developed countries?
Your answer should be compact. 4.23. What is the difference between the highest and the lowest Mortality rate(per 1,000 live births) in Swaziland?
Your answer should be very brief. 1.8. 